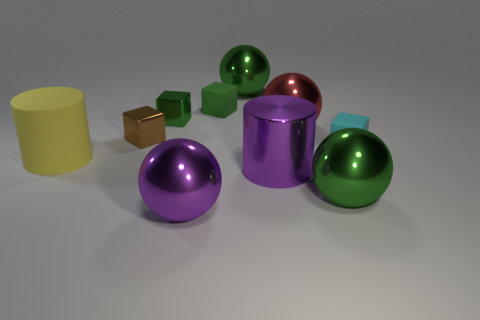Could you estimate the sizes of these objects? Without a reference object of known size, it's difficult to provide precise measurements. However, they appear to be roughly comparable to what one might find on a desktop, with the blocks being a few centimeters in dimension and the spheres and cylinders being slightly larger, possibly around 10 to 20 centimeters in diameter. How might the various shapes depicted interact with light differently? The reflective surfaces of the spheres and cylinder likely scatter light uniformly in all directions, displaying highlights and reflections clearly, while the matte surfaces of the blocks would diffuse light more evenly, showing fewer highlights and potentially absorbing more light. This would result in the spheres and cylinder appearing more lustrous and the blocks more subdued. 